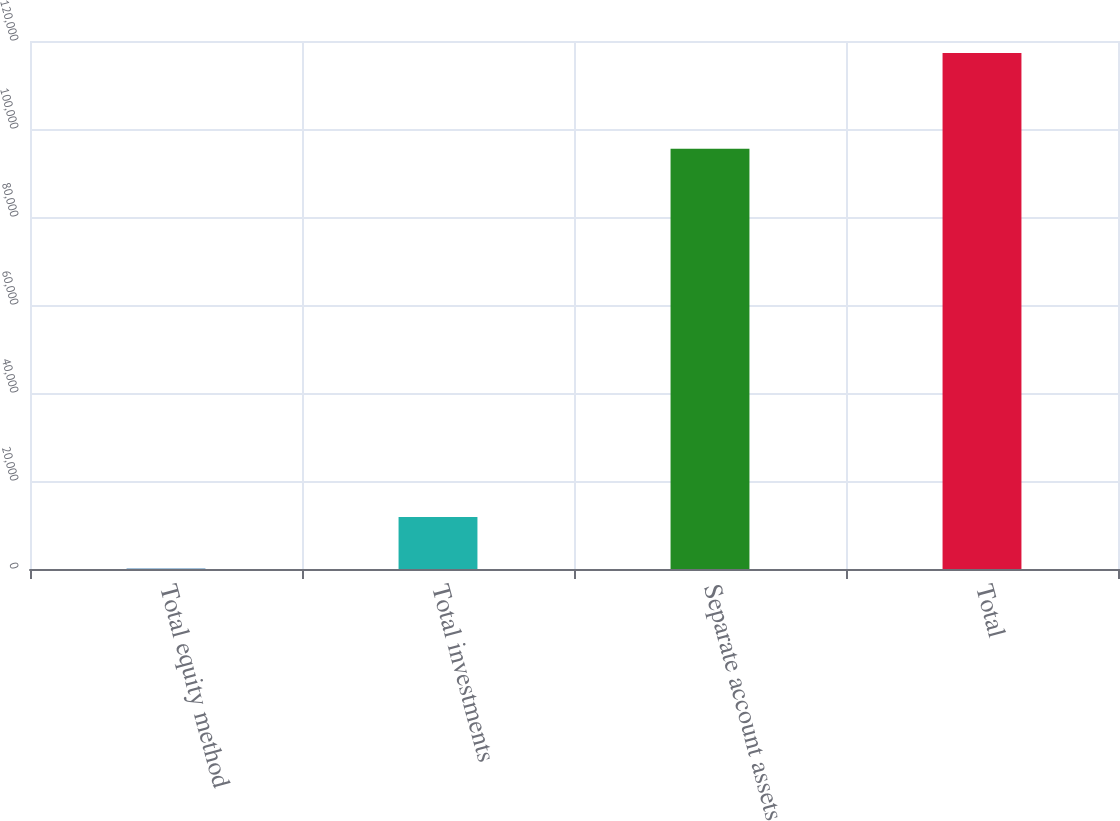Convert chart to OTSL. <chart><loc_0><loc_0><loc_500><loc_500><bar_chart><fcel>Total equity method<fcel>Total investments<fcel>Separate account assets<fcel>Total<nl><fcel>122<fcel>11839.4<fcel>95514<fcel>117296<nl></chart> 